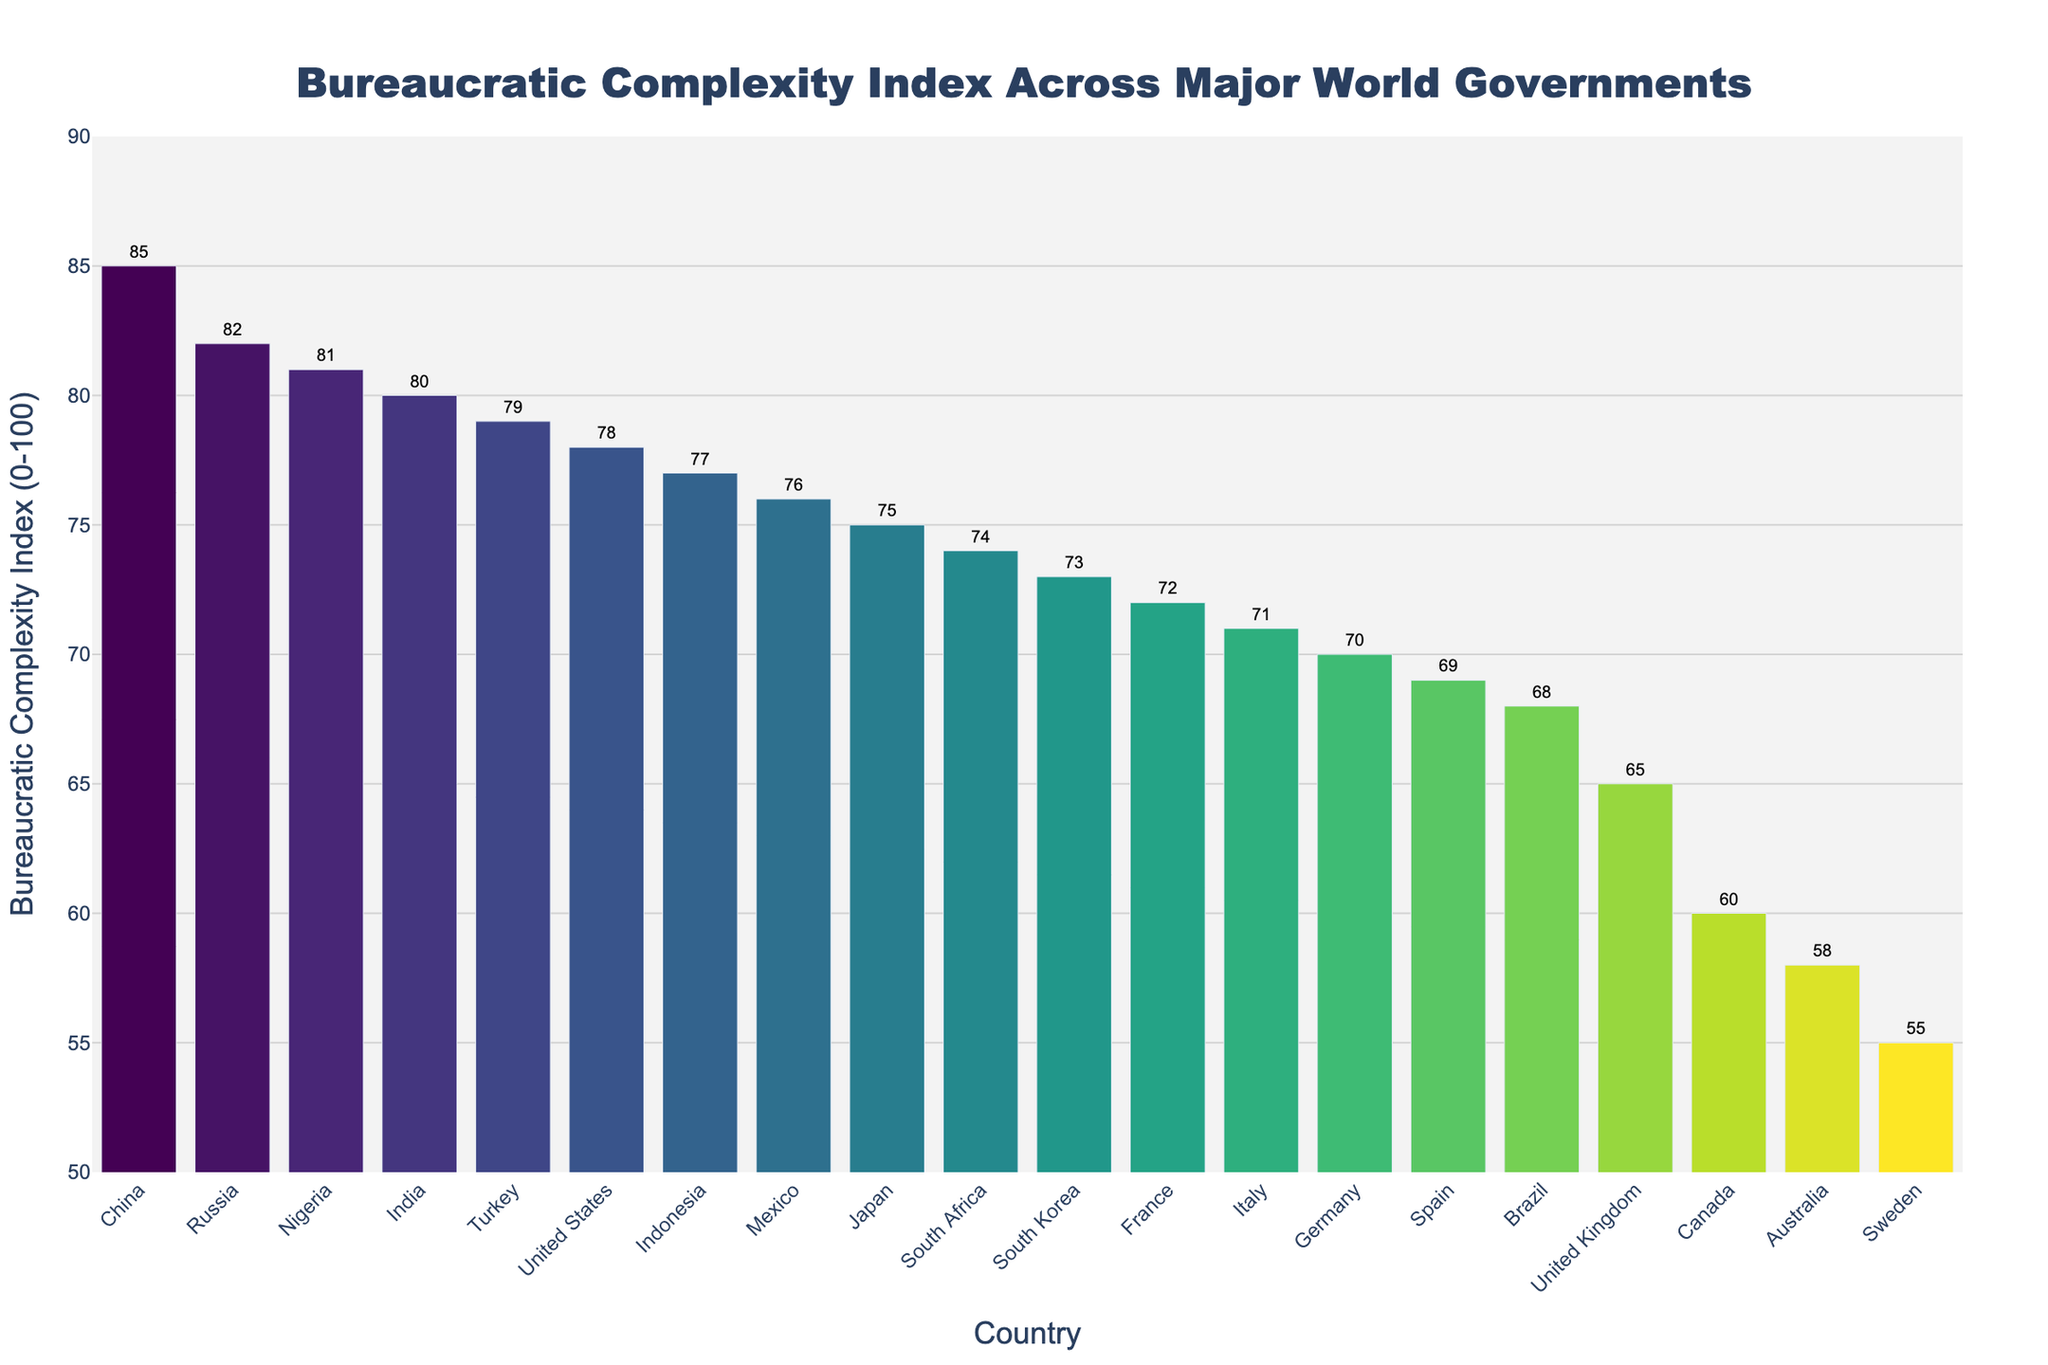What is the Bureaucratic Complexity Index of China? Look at the bar for China and refer to the value displayed above it. The value shown is 85.
Answer: 85 Which country has the lowest Bureaucratic Complexity Index? Identify the shortest bar in the chart and refer to the value above it. The shortest bar represents Sweden with a value of 55.
Answer: Sweden How does the Bureaucratic Complexity Index of the United States compare to that of Japan? Compare the heights of the bars for the United States and Japan, and refer to their respective values. The United States has an index of 78 while Japan has an index of 75.
Answer: The United States has a higher index than Japan What is the average Bureaucratic Complexity Index of the G7 countries (United States, Canada, France, Germany, Italy, Japan, United Kingdom)? Sum the Bureaucratic Complexity Index values of the G7 countries (78 + 60 + 72 + 70 + 71 + 75 + 65) and divide by the number of countries (7). The sum is 491 and the average is 491/7 = 70.14.
Answer: 70.14 What is the combined Bureaucratic Complexity Index of Turkey and Indonesia? Add the Bureaucratic Complexity Index values of Turkey and Indonesia. Turkey has an index of 79 and Indonesia has an index of 77. The sum is 79 + 77 = 156.
Answer: 156 Compare the Bureaucratic Complexity Index of Russia and Nigeria. Which country has a higher index? Look at the height of the bars for Russia and Nigeria and refer to their respective values. Russia has an index of 82 while Nigeria has an index of 81.
Answer: Russia Which two countries have the closest Bureaucratic Complexity Index values? Identify the pairs of countries with the smallest difference in their Bureaucratic Complexity Index values. The closest values are for Germany (70) and Italy (71), with a difference of just 1.
Answer: Germany and Italy What is the range of Bureaucratic Complexity Index values represented in the chart? Subtract the smallest Bureaucratic Complexity Index value (Sweden with 55) from the largest (China with 85). The range is 85 - 55 = 30.
Answer: 30 How many countries have a Bureaucratic Complexity Index greater than 75? Count the bars with values greater than 75. The countries are China (85), Russia (82), India (80), Turkey (79), Indonesia (77), Nigeria (81), and the United States (78) — a total of 7 countries.
Answer: 7 